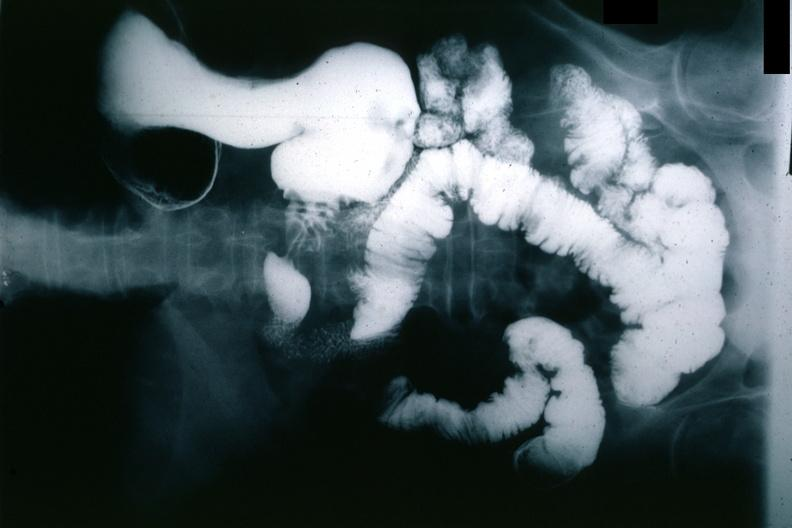what is present?
Answer the question using a single word or phrase. Stomach 